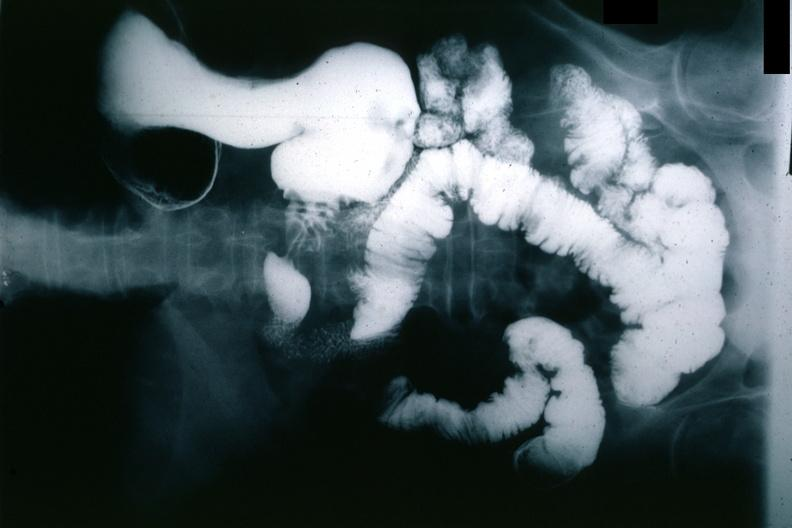what is present?
Answer the question using a single word or phrase. Stomach 